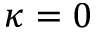Convert formula to latex. <formula><loc_0><loc_0><loc_500><loc_500>\kappa = 0</formula> 